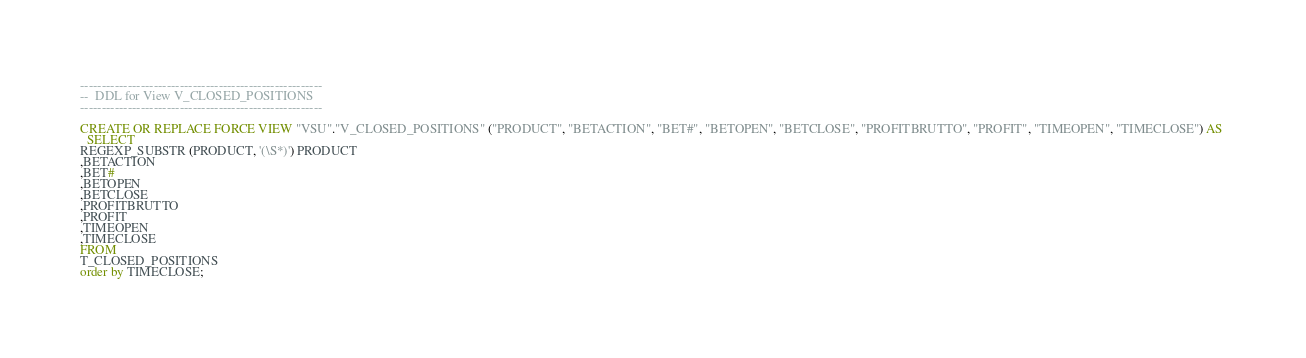Convert code to text. <code><loc_0><loc_0><loc_500><loc_500><_SQL_>--------------------------------------------------------
--  DDL for View V_CLOSED_POSITIONS
--------------------------------------------------------

CREATE OR REPLACE FORCE VIEW "VSU"."V_CLOSED_POSITIONS" ("PRODUCT", "BETACTION", "BET#", "BETOPEN", "BETCLOSE", "PROFITBRUTTO", "PROFIT", "TIMEOPEN", "TIMECLOSE") AS 
  SELECT 
REGEXP_SUBSTR (PRODUCT, '(\S*)') PRODUCT
,BETACTION
,BET#
,BETOPEN
,BETCLOSE
,PROFITBRUTTO
,PROFIT
,TIMEOPEN
,TIMECLOSE
FROM 
T_CLOSED_POSITIONS
order by TIMECLOSE;
</code> 